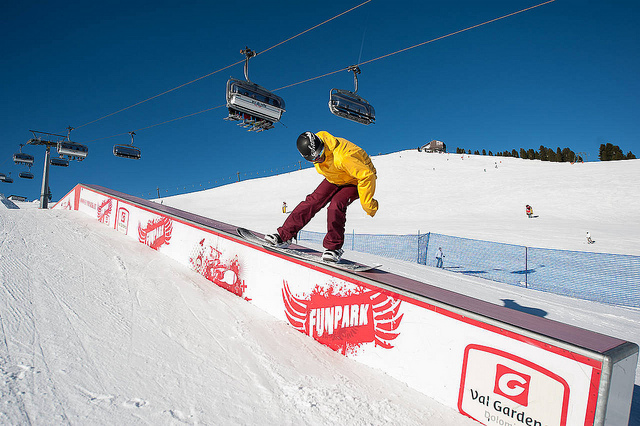Identify the text displayed in this image. FUNPARK G Val Garden Garc 